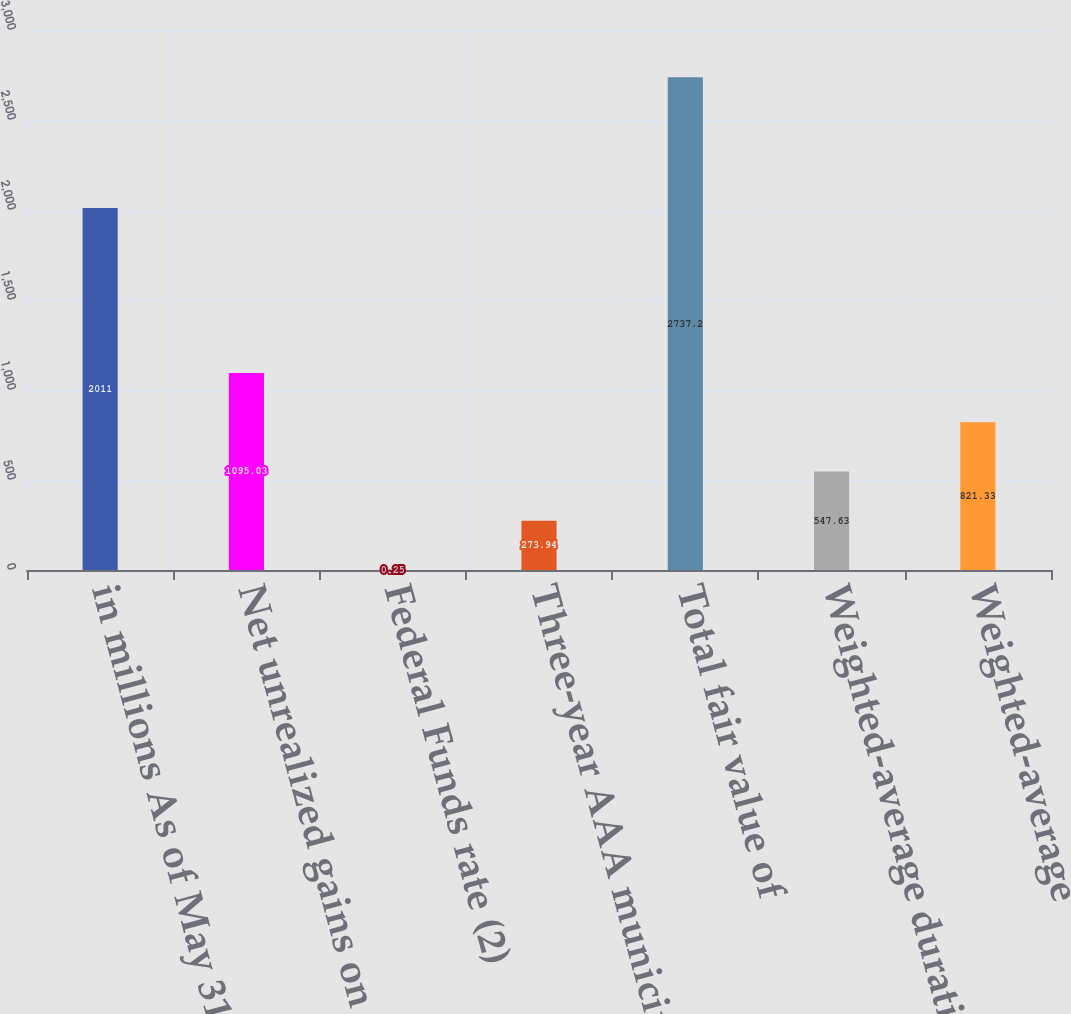Convert chart. <chart><loc_0><loc_0><loc_500><loc_500><bar_chart><fcel>in millions As of May 31<fcel>Net unrealized gains on<fcel>Federal Funds rate (2)<fcel>Three-year AAA municipal<fcel>Total fair value of<fcel>Weighted-average duration of<fcel>Weighted-average<nl><fcel>2011<fcel>1095.03<fcel>0.25<fcel>273.94<fcel>2737.2<fcel>547.63<fcel>821.33<nl></chart> 